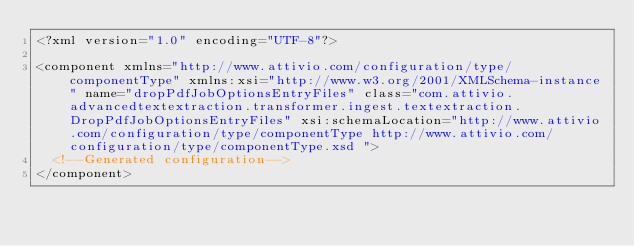Convert code to text. <code><loc_0><loc_0><loc_500><loc_500><_XML_><?xml version="1.0" encoding="UTF-8"?>

<component xmlns="http://www.attivio.com/configuration/type/componentType" xmlns:xsi="http://www.w3.org/2001/XMLSchema-instance" name="dropPdfJobOptionsEntryFiles" class="com.attivio.advancedtextextraction.transformer.ingest.textextraction.DropPdfJobOptionsEntryFiles" xsi:schemaLocation="http://www.attivio.com/configuration/type/componentType http://www.attivio.com/configuration/type/componentType.xsd ">
  <!--Generated configuration-->
</component>
</code> 